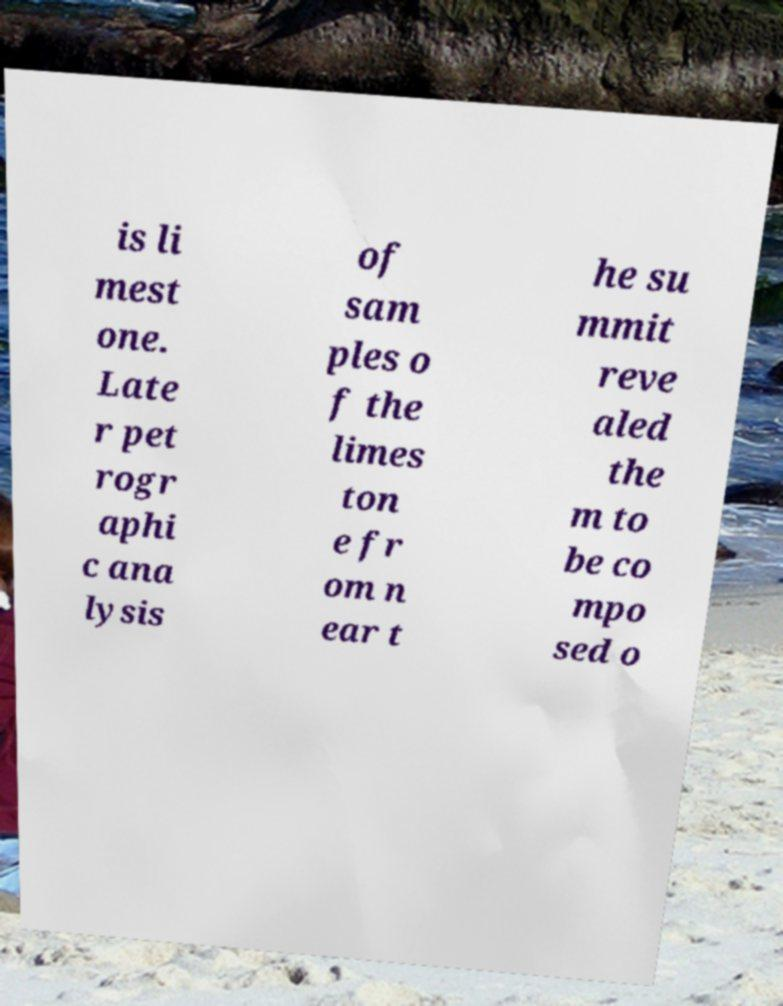Could you assist in decoding the text presented in this image and type it out clearly? is li mest one. Late r pet rogr aphi c ana lysis of sam ples o f the limes ton e fr om n ear t he su mmit reve aled the m to be co mpo sed o 